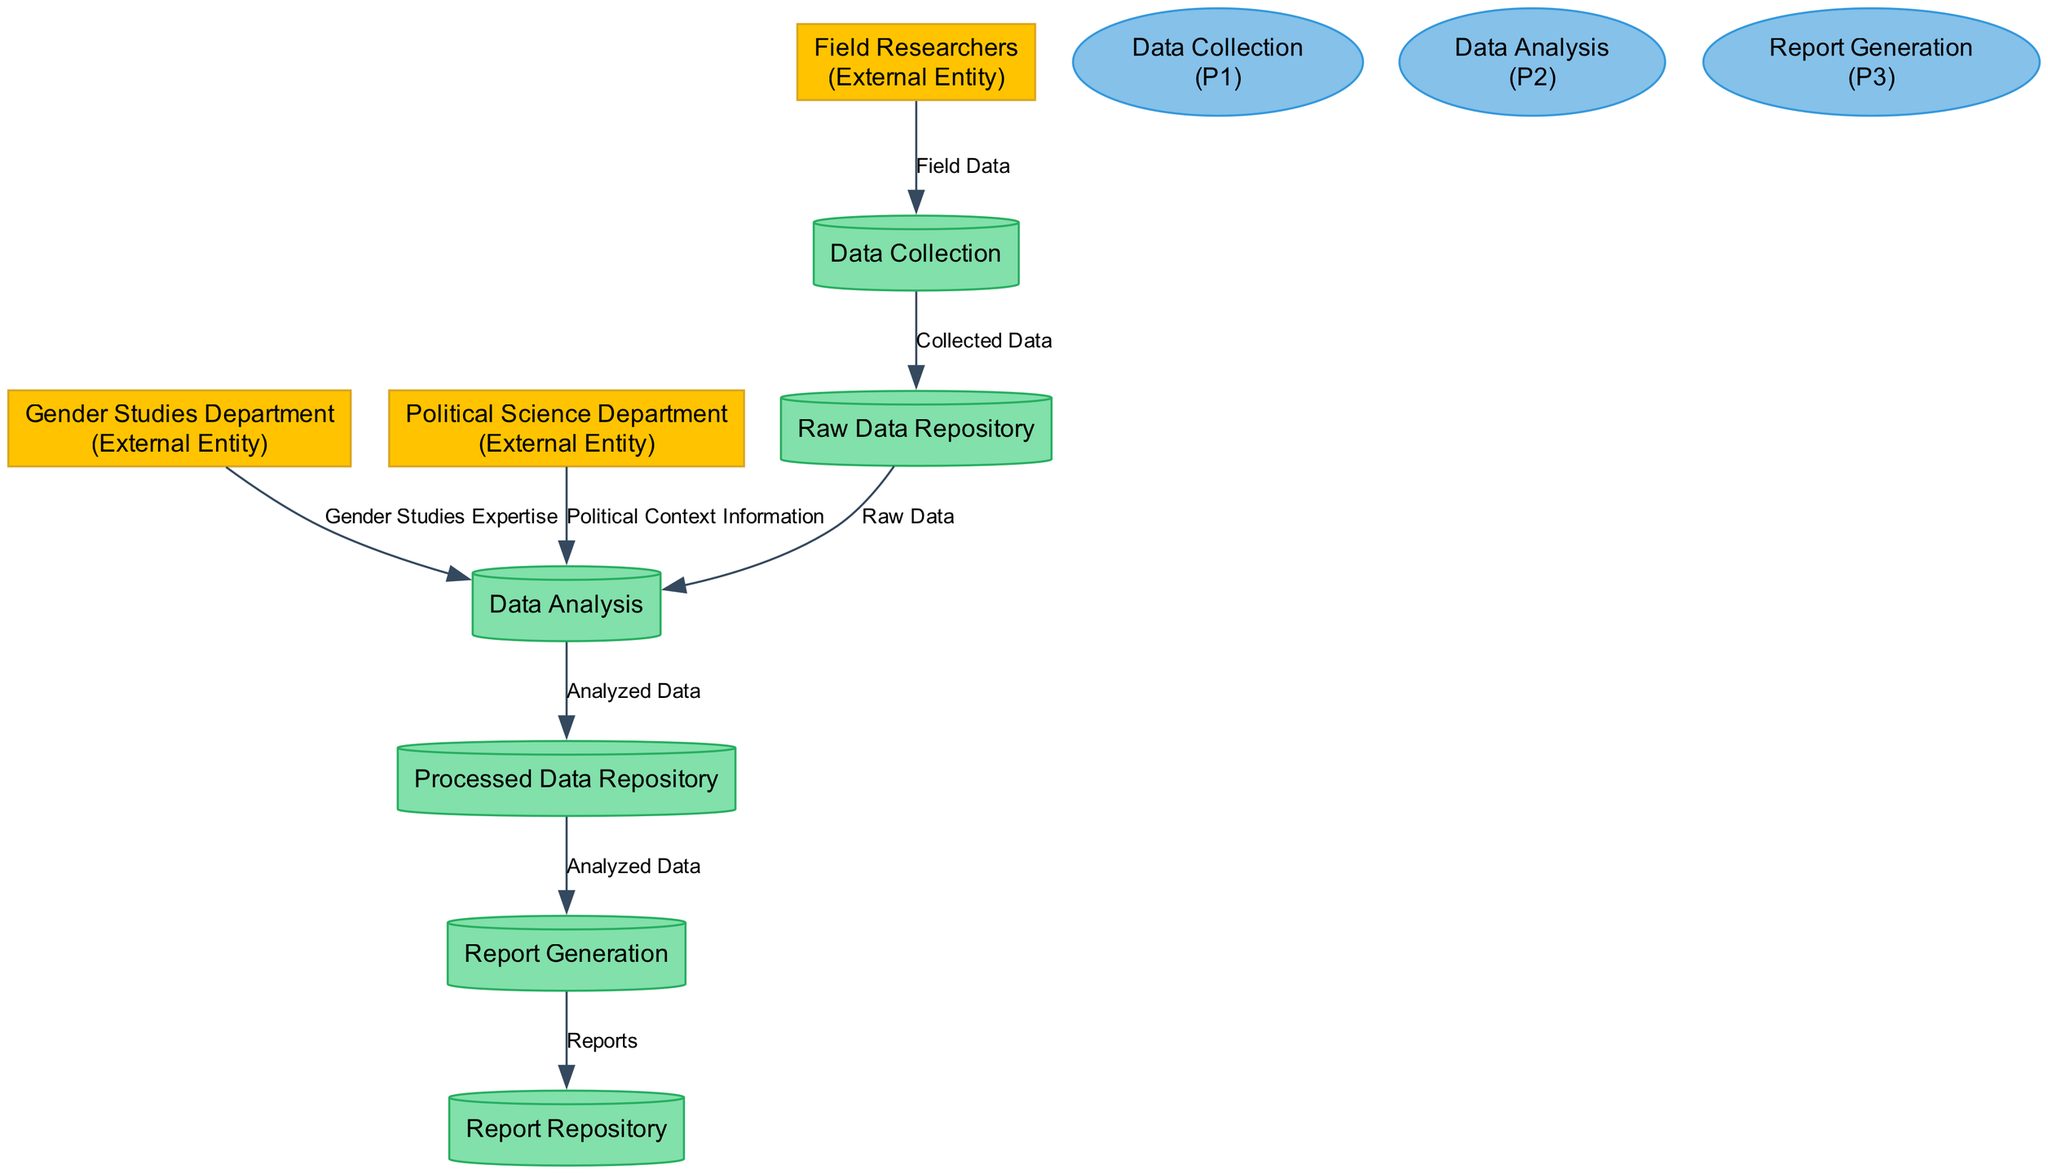What are the external entities involved in this diagram? The diagram features three external entities: the Gender Studies Department, the Political Science Department, and Field Researchers. Each plays a role in the workflow related to gender disparities in South African politics.
Answer: Gender Studies Department, Political Science Department, Field Researchers What process is responsible for generating reports? The Report Generation process is explicitly named as responsible for creating reports based on the analyzed data. It is one of the three main processes identified in the diagram.
Answer: Report Generation How many data stores are there in the diagram? There are three data stores identified: Raw Data Repository, Processed Data Repository, and Report Repository. This count reflects all distinct storage locations present in the diagram.
Answer: 3 What data flows from the Data Collection process to the Raw Data Repository? The data flow from the Data Collection process to the Raw Data Repository is labeled as "Collected Data," indicating the type of information transferred to storage after collection.
Answer: Collected Data Which departments provide expertise to the Data Analysis process? The Gender Studies Department and the Political Science Department both contribute expertise to the Data Analysis process, facilitating a comprehensive understanding of the data.
Answer: Gender Studies Department, Political Science Department What type of data is stored in the Processed Data Repository? The Processed Data Repository stores "Analyzed Data," indicating that it contains data that has already been processed and analyzed for insights regarding gender disparities.
Answer: Analyzed Data What is the initial source of data for the Data Collection process? The initial source of data for the Data Collection process is the Field Researchers, who collect field data on gender disparities as their primary role.
Answer: Field Researchers Which process comes after Data Analysis in the workflow? The Report Generation process follows directly after Data Analysis, demonstrating that reports are created based on the results and insights gained from the analyzed data.
Answer: Report Generation What type of expertise is provided by the Gender Studies Department to the Data Analysis process? The expertise provided by the Gender Studies Department is classified as "Gender Studies Expertise," which is crucial for understanding the nuances of gender disparities in politics.
Answer: Gender Studies Expertise 